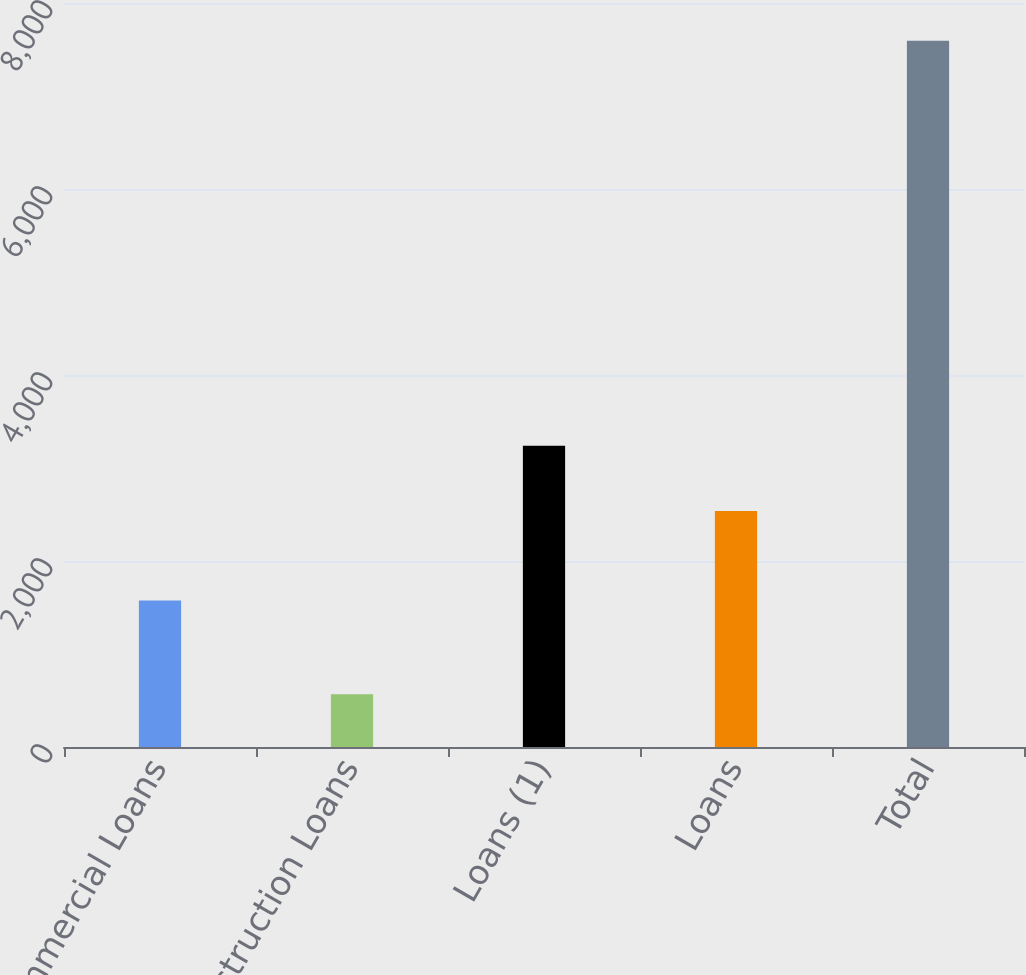Convert chart. <chart><loc_0><loc_0><loc_500><loc_500><bar_chart><fcel>Commercial Loans<fcel>Construction Loans<fcel>Loans (1)<fcel>Loans<fcel>Total<nl><fcel>1574<fcel>567<fcel>3239.6<fcel>2537<fcel>7593<nl></chart> 